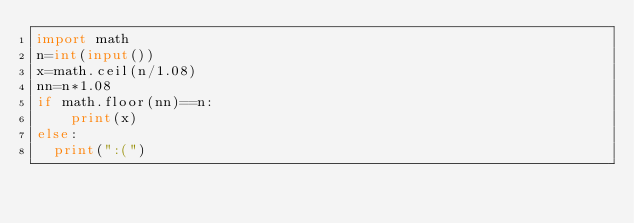<code> <loc_0><loc_0><loc_500><loc_500><_Python_>import math
n=int(input())
x=math.ceil(n/1.08)
nn=n*1.08
if math.floor(nn)==n:    
	print(x)
else:
  print(":(")
</code> 